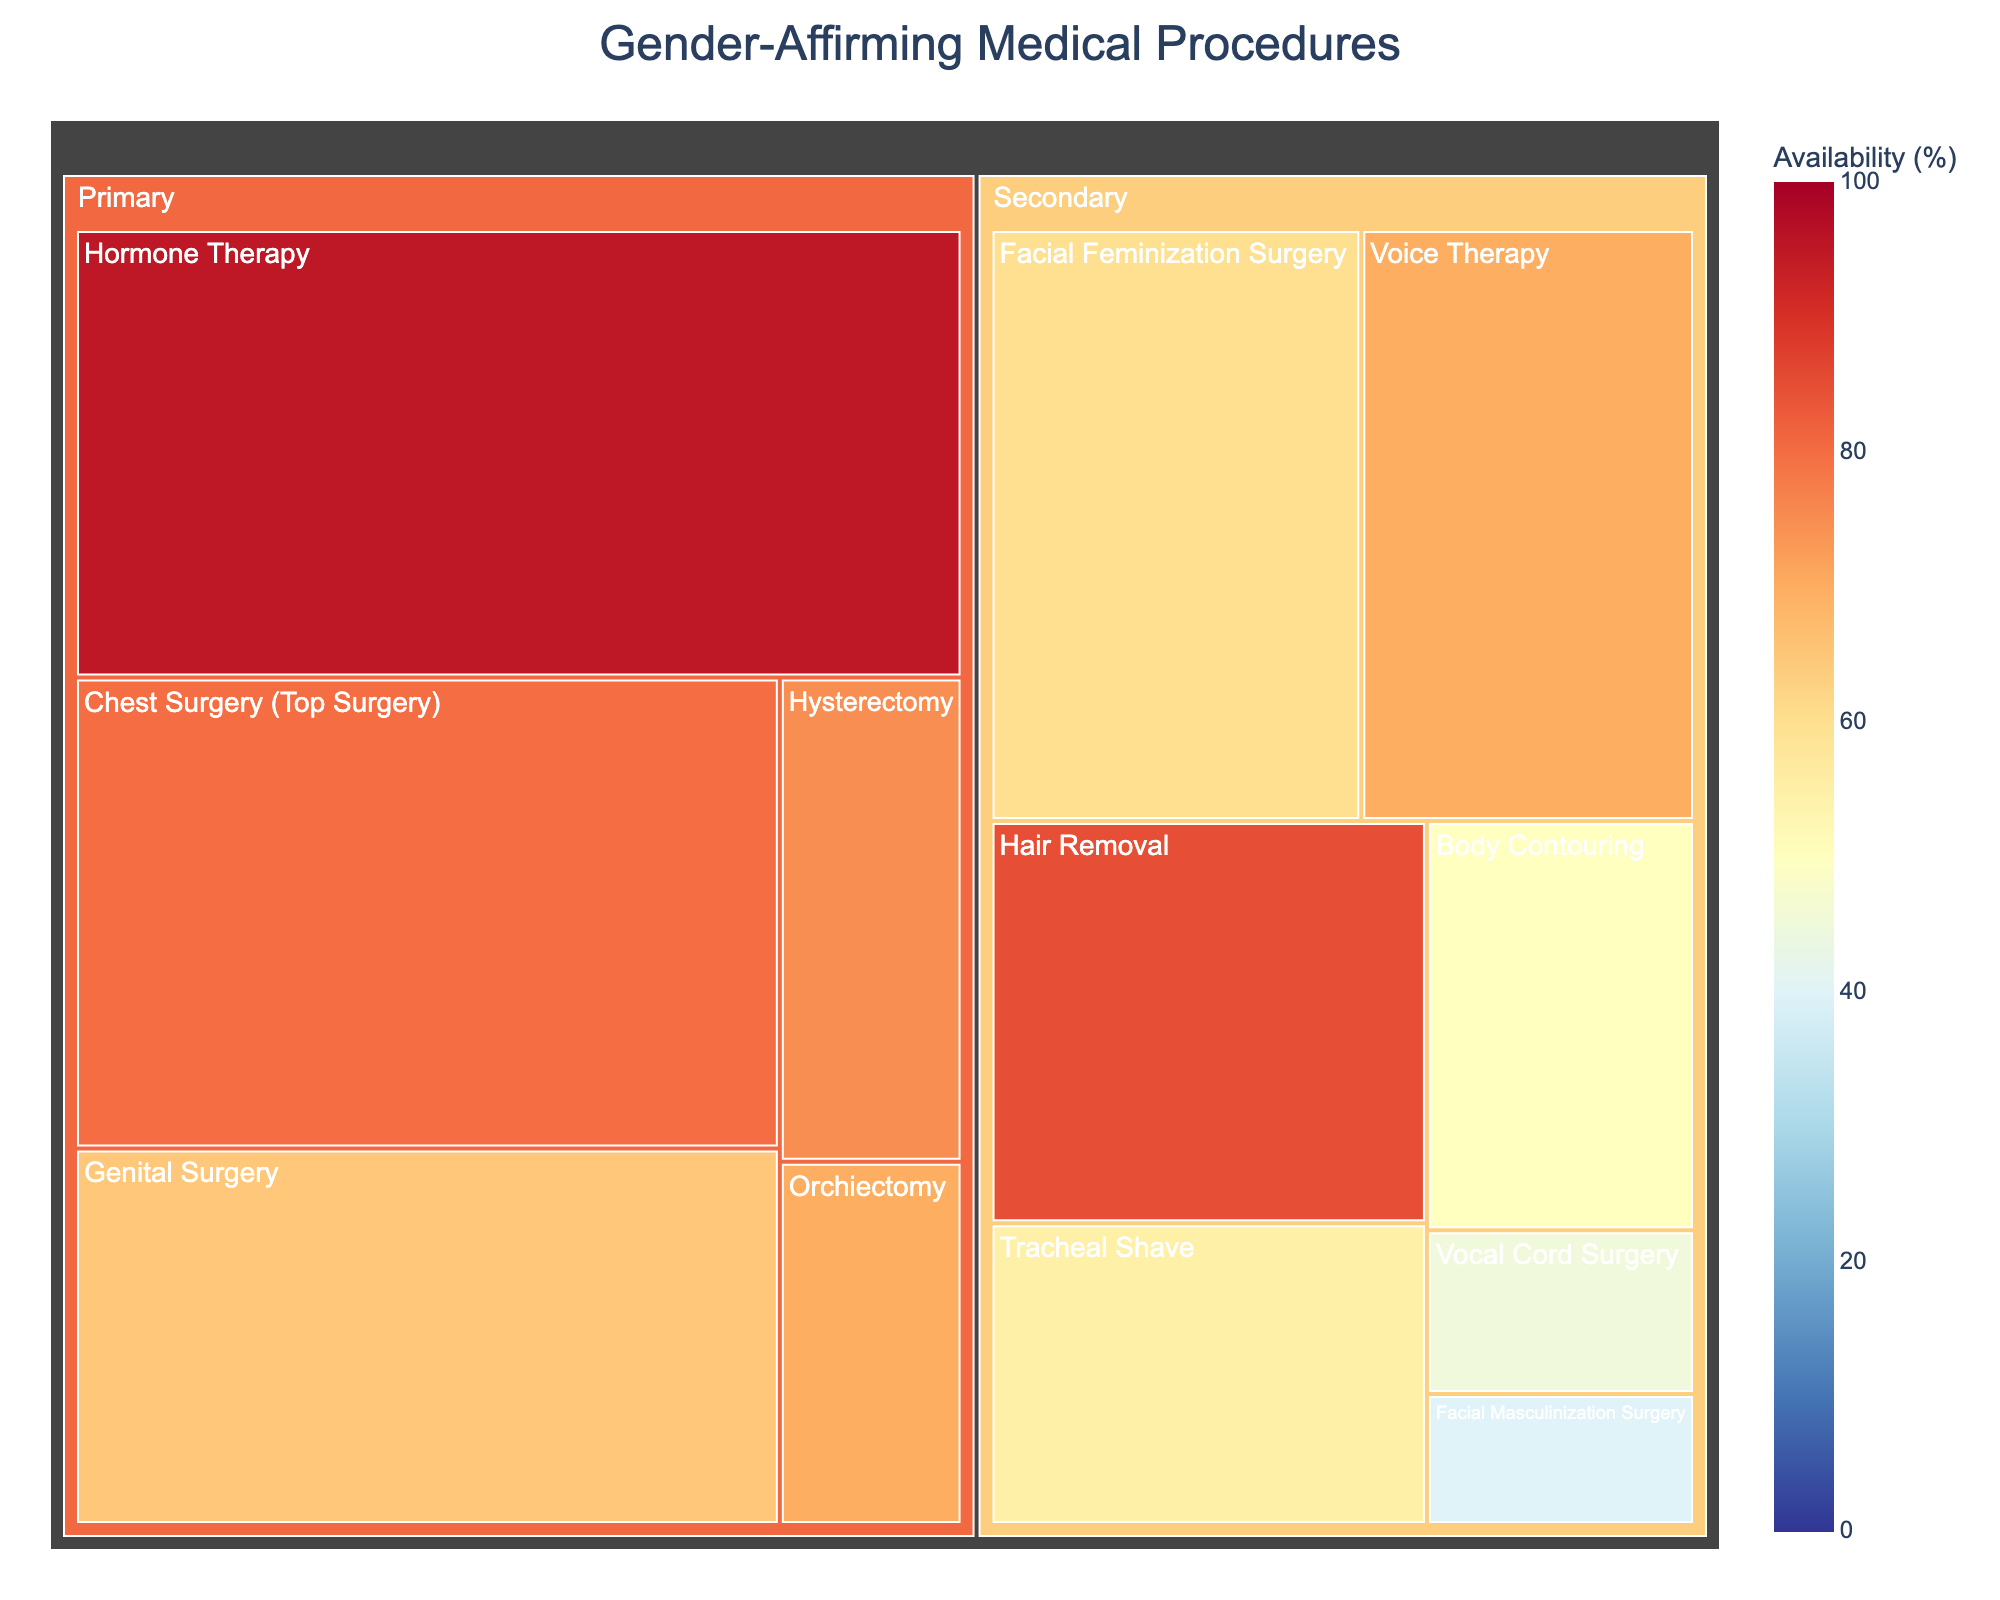what is the most popular gender-affirming medical procedure shown in the figure? By looking at the treemap, we can identify the most popular procedure by finding the largest section in terms of area under the category 'Primary'. The procedure with the highest popularity will have the largest size. In this case, Hormone Therapy has the largest area under 'Primary'.
Answer: Hormone Therapy What is the color range used in the figure to represent availability? The color range representing availability is indicated by a color bar which varies from light to dark shade. The title of the color bar shows that it ranges from 0% to 100%.
Answer: 0% to 100% Which secondary gender-affirming procedure has the highest availability? To find this, we need to look at the secondary category procedures and check the one with the darkest color, as it represents higher availability. Hair Removal appears to have the darkest shade with the highest availability.
Answer: Hair Removal What is the availability of Chest Surgery (Top Surgery)? By locating the Chest Surgery (Top Surgery) section on the treemap, we can hover over or refer to the color and look for the exact availability value. The data shows it as 80%.
Answer: 80% Which category, Primary or Secondary, has a procedure with the lowest popularity? To determine this, look at both categories for the procedure with the smallest section. Orchardectomy in Primary has a popularity of 15, while Vocal Cord Surgery in Secondary has a popularity of 10. The lowest is thus in the Secondary category.
Answer: Secondary What is the average availability of the procedures in the primary category? The sum of availability percentages for the procedures in the primary category (Hormone Therapy, Chest Surgery, Genital Surgery, Hysterectomy, and Orchiectomy) is (95 + 80 + 65 + 75 + 70 = 385). There are 5 procedures, so the average is 385/5 = 77%.
Answer: 77% How does the popularity of Voice Therapy compare to that of Tracheal Shave? We compare the popularity values of Voice Therapy (45) and Tracheal Shave (30). Voice Therapy has a higher popularity than Tracheal Shave.
Answer: Higher Which gender-affirming procedure has both popularity and availability below 50%? By examining the treemap, we can find procedures with both attributes below 50%. Vocal Cord Surgery and Facial Masculinization Surgery have their popularity and availability below 50%.
Answer: Vocal Cord Surgery and Facial Masculinization Surgery 